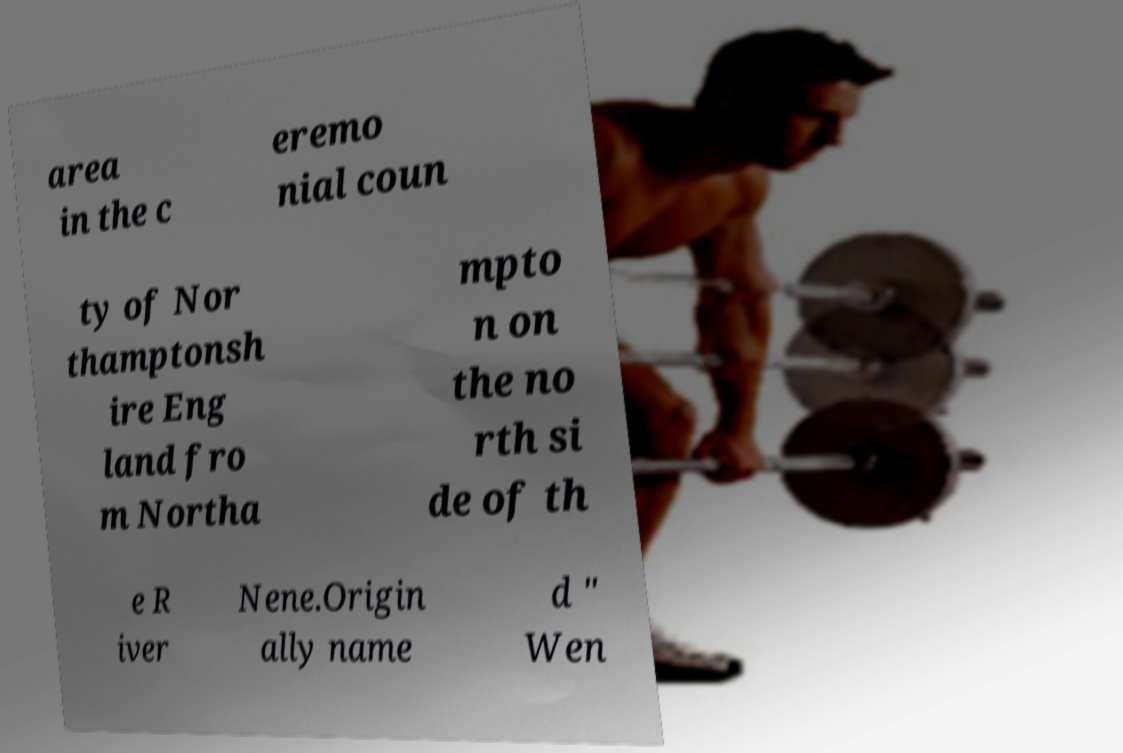Could you extract and type out the text from this image? area in the c eremo nial coun ty of Nor thamptonsh ire Eng land fro m Northa mpto n on the no rth si de of th e R iver Nene.Origin ally name d " Wen 